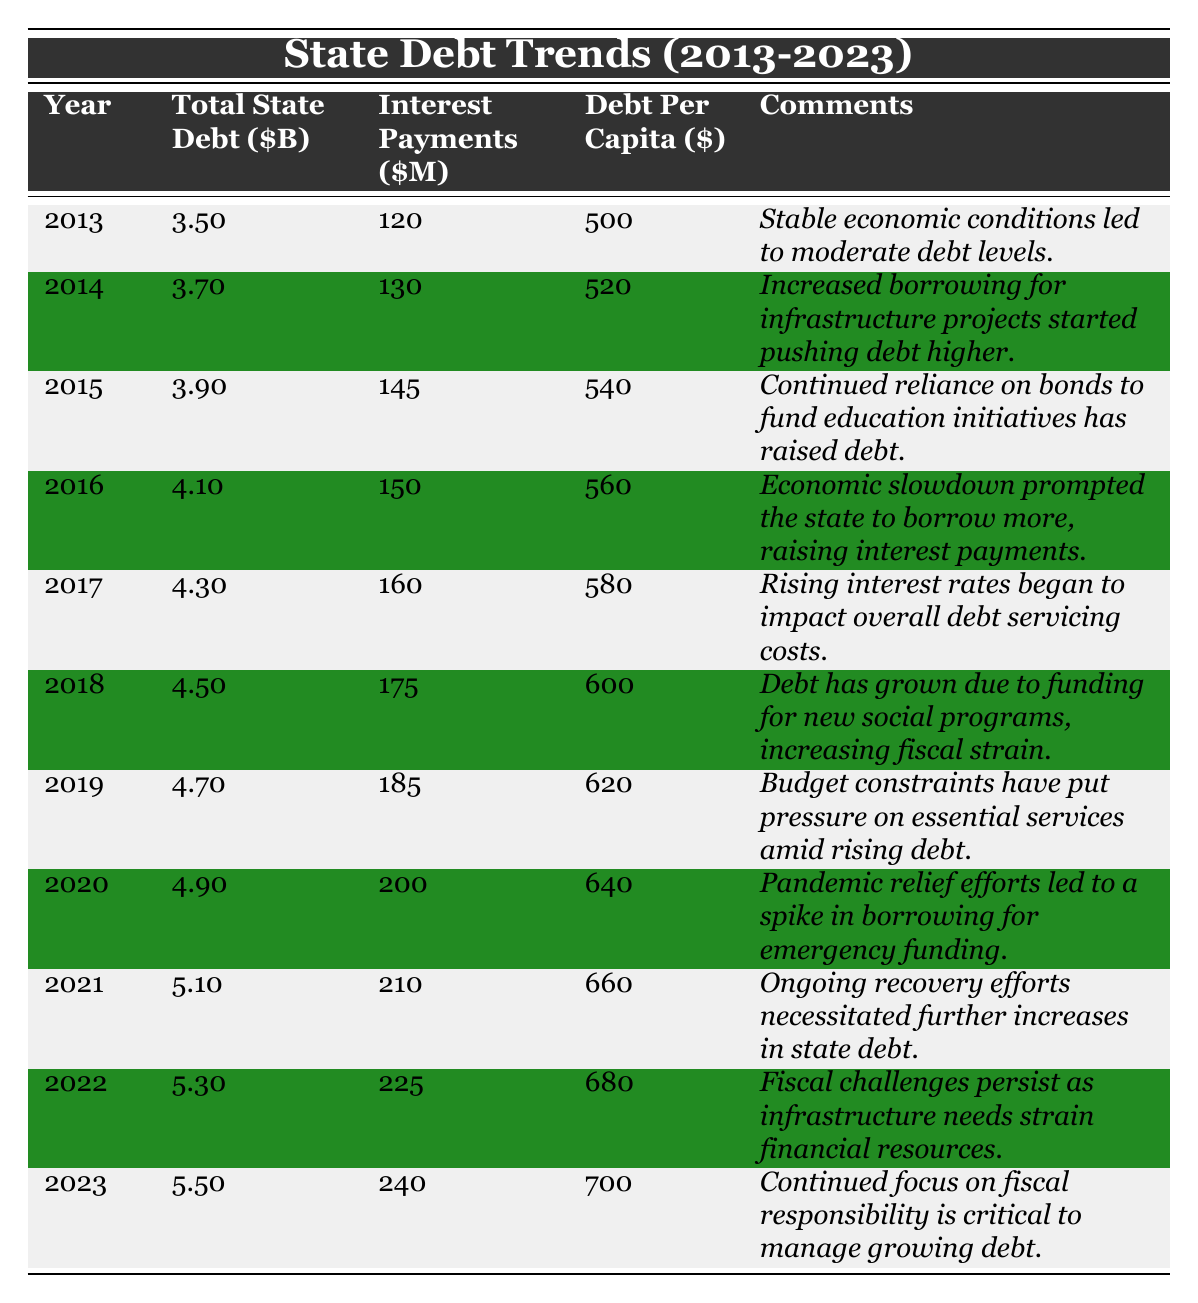What was the total state debt in 2020? The table shows the total state debt for the year 2020 listed as 4.90 billion dollars.
Answer: 4.90 billion dollars What were the interest payments in 2019? According to the table, the interest payments for 2019 were 185 million dollars.
Answer: 185 million dollars How much did the total state debt increase from 2013 to 2023? The total state debt in 2013 was 3.50 billion dollars and in 2023 it was 5.50 billion dollars. The increase is 5.50 - 3.50 = 2.00 billion dollars.
Answer: 2.00 billion dollars What is the average debt per capita from 2013 to 2023? To find the average, we first sum the debt per capita over the years (500 + 520 + 540 + 560 + 580 + 600 + 620 + 640 + 660 + 680 + 700) = 6,200. Then divide by 11 (the number of years): 6,200/11 ≈ 564.54.
Answer: Approximately 564.54 dollars Did interest payments exceed 200 million dollars in any year? By examining the table, we see that interest payments for the years 2020, 2021, 2022, and 2023 are 200 million dollars and above. Therefore, yes, interest payments exceeded 200 million dollars in these years.
Answer: Yes What was the total state debt in 2018 compared to the overall increase in interest payments from 2013 to 2018? In 2018, total state debt was 4.50 billion dollars. To find the increase in interest payments from 2013 (120 million dollars) to 2018 (175 million dollars), we calculate 175 - 120 = 55 million dollars increase.
Answer: 4.50 billion dollars; 55 million dollars increase What is the relationship between interest payments and total state debt from 2013 to 2023? The table shows that as total state debt increases each year, interest payments also trend upwards. This indicates a positive correlation between the two; higher debt levels lead to higher interest payments.
Answer: Positive correlation Which year saw the highest increase in total state debt compared to the previous year? By reviewing the yearly changes in total state debt, we see the largest increase was from 2022 to 2023: from 5.30 billion to 5.50 billion, an increase of 0.20 billion dollars, which is the largest single-year increase in the entire period.
Answer: From 2022 to 2023 What were the most significant reasons for the increases in total state debt over the years according to the comments? The comments highlight increased borrowing for infrastructure (2014), funding for education initiatives (2015), and emergency pandemic relief efforts (2020) as significant reasons for the debt increases.
Answer: Increased borrowing for specific projects and emergency relief efforts 